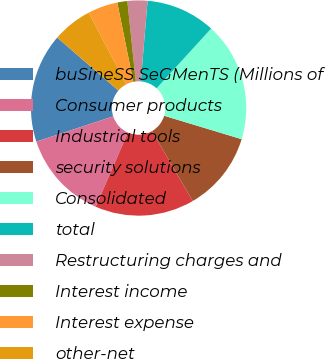<chart> <loc_0><loc_0><loc_500><loc_500><pie_chart><fcel>buSineSS SeGMenTS (Millions of<fcel>Consumer products<fcel>Industrial tools<fcel>security solutions<fcel>Consolidated<fcel>total<fcel>Restructuring charges and<fcel>Interest income<fcel>Interest expense<fcel>other-net<nl><fcel>16.41%<fcel>13.43%<fcel>14.92%<fcel>11.94%<fcel>17.9%<fcel>10.45%<fcel>3.0%<fcel>1.51%<fcel>4.49%<fcel>5.98%<nl></chart> 